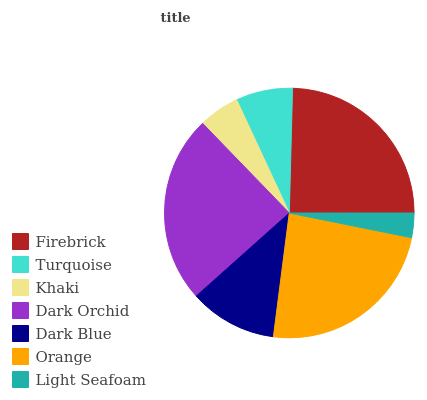Is Light Seafoam the minimum?
Answer yes or no. Yes. Is Firebrick the maximum?
Answer yes or no. Yes. Is Turquoise the minimum?
Answer yes or no. No. Is Turquoise the maximum?
Answer yes or no. No. Is Firebrick greater than Turquoise?
Answer yes or no. Yes. Is Turquoise less than Firebrick?
Answer yes or no. Yes. Is Turquoise greater than Firebrick?
Answer yes or no. No. Is Firebrick less than Turquoise?
Answer yes or no. No. Is Dark Blue the high median?
Answer yes or no. Yes. Is Dark Blue the low median?
Answer yes or no. Yes. Is Firebrick the high median?
Answer yes or no. No. Is Light Seafoam the low median?
Answer yes or no. No. 